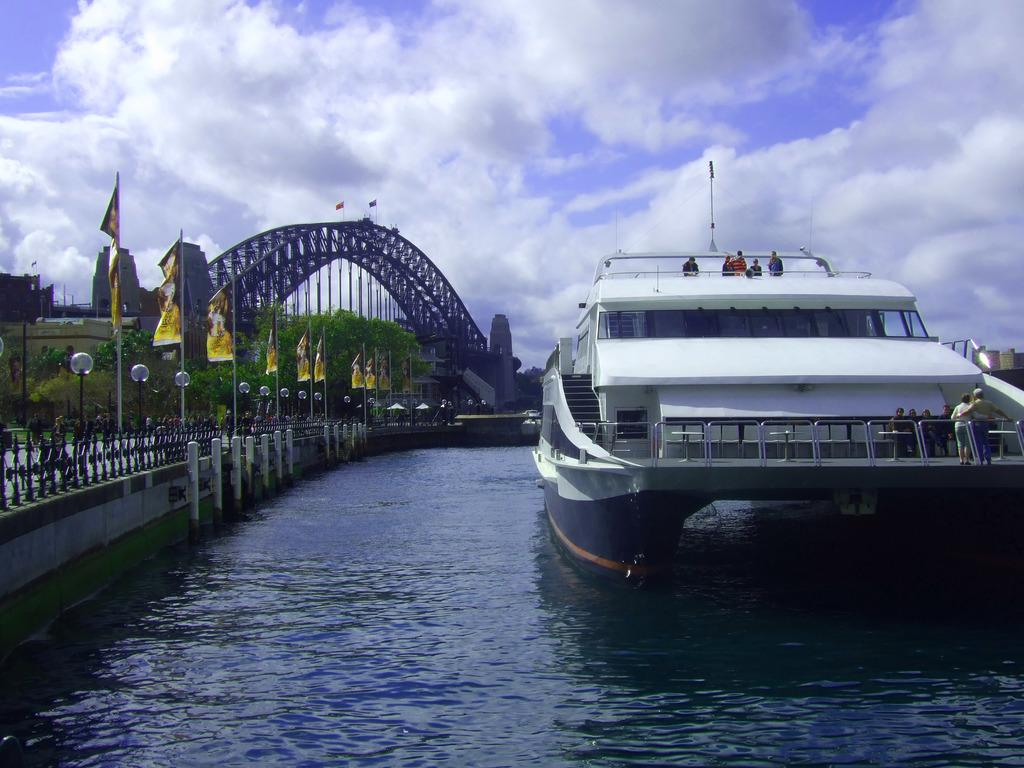What is the main subject of the image? The main subject of the image is a ship. Where is the ship located? The ship is on the water. What can be seen to the left of the ship? There is railing and flags to the left of the ship. What is visible in the background of the image? There are many trees, a bridge, clouds in the sky, and the sky itself visible in the background of the image. How many dolls are sitting on the bridge in the image? There are no dolls present in the image, and therefore no dolls can be seen on the bridge. What type of berry is growing on the trees in the background of the image? There is no indication of any berries growing on the trees in the image. 